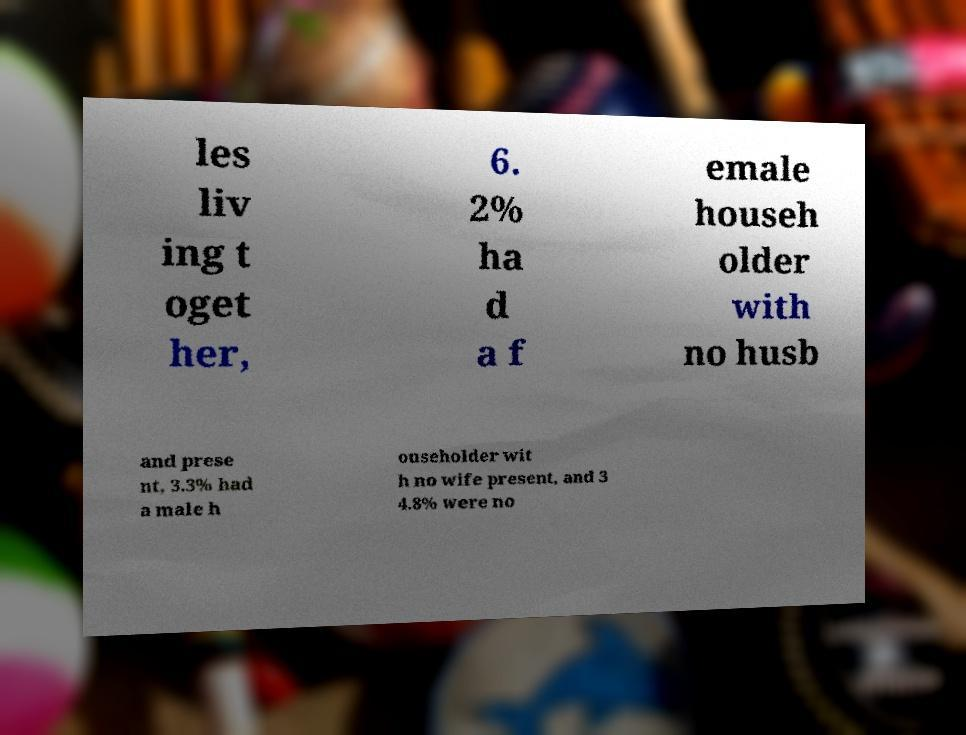Could you assist in decoding the text presented in this image and type it out clearly? les liv ing t oget her, 6. 2% ha d a f emale househ older with no husb and prese nt, 3.3% had a male h ouseholder wit h no wife present, and 3 4.8% were no 